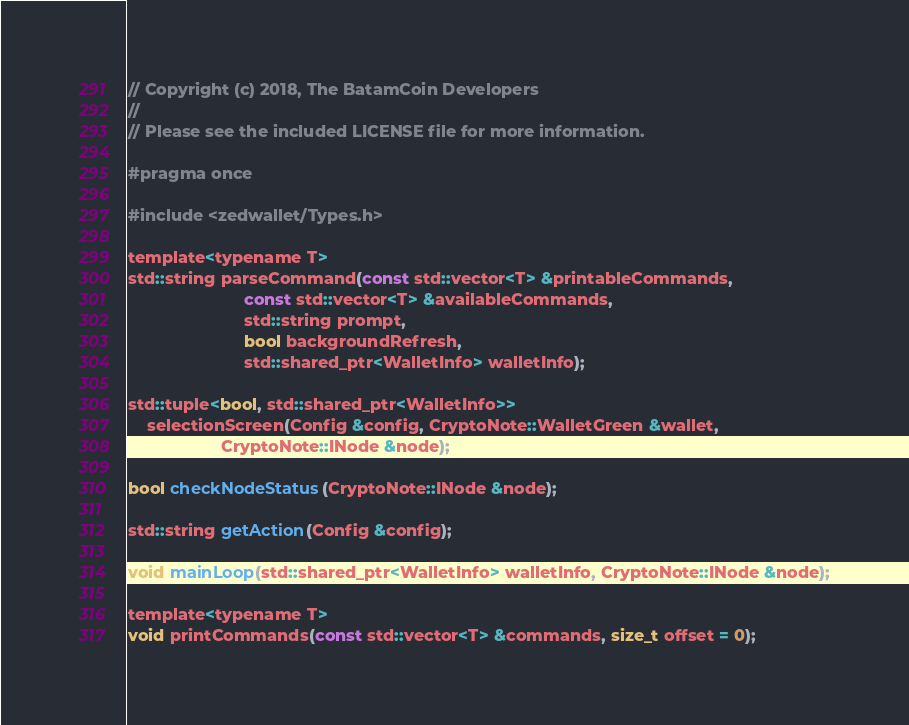<code> <loc_0><loc_0><loc_500><loc_500><_C_>// Copyright (c) 2018, The BatamCoin Developers
// 
// Please see the included LICENSE file for more information.

#pragma once

#include <zedwallet/Types.h>

template<typename T>
std::string parseCommand(const std::vector<T> &printableCommands,
                         const std::vector<T> &availableCommands,
                         std::string prompt,
                         bool backgroundRefresh,
                         std::shared_ptr<WalletInfo> walletInfo);

std::tuple<bool, std::shared_ptr<WalletInfo>>
    selectionScreen(Config &config, CryptoNote::WalletGreen &wallet,
                    CryptoNote::INode &node);

bool checkNodeStatus(CryptoNote::INode &node);

std::string getAction(Config &config);

void mainLoop(std::shared_ptr<WalletInfo> walletInfo, CryptoNote::INode &node);

template<typename T>
void printCommands(const std::vector<T> &commands, size_t offset = 0);
</code> 